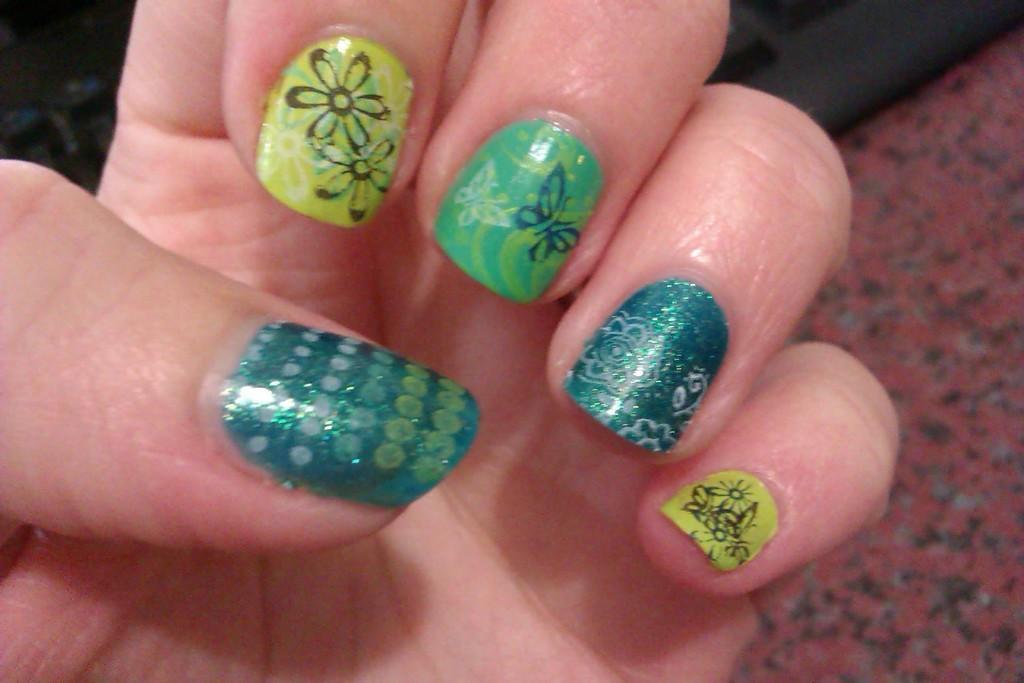In one or two sentences, can you explain what this image depicts? In this image there is a nail polish to the person's fingers and a black color object on the ground. 